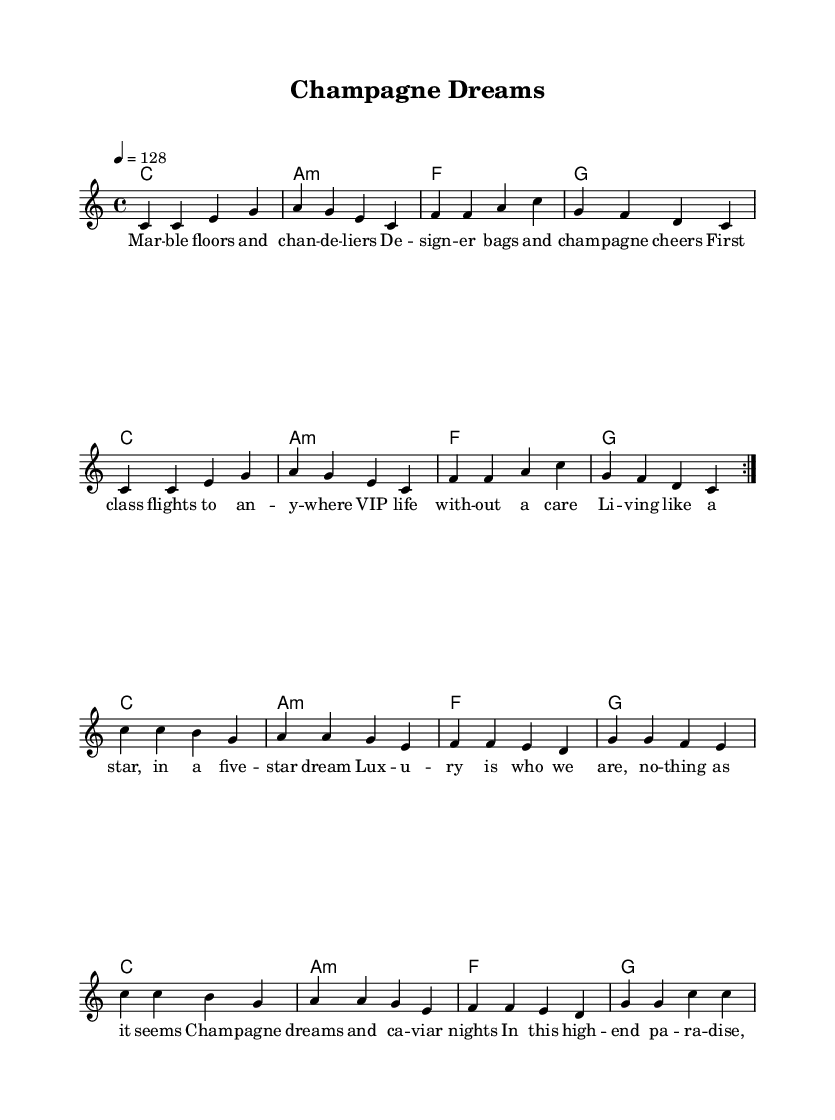What is the key signature of this music? The key signature is C major, which has no sharps or flats.
Answer: C major What is the time signature of the music? The time signature is indicated as 4/4, meaning there are four beats in a measure.
Answer: 4/4 What is the tempo of the piece? The tempo marking indicates 128 beats per minute, denoted by "4 = 128."
Answer: 128 How many measures are used in the chorus? The chorus consists of 8 measures as indicated by the lyric structure and total count of the lines.
Answer: 8 What type of bag is referenced in the lyrics? The lyrics mention "designer bags," indicating luxury items associated with high-end fashion.
Answer: designer bags What kind of lifestyle does the song portray? The lyrics depict a "VIP life" and experiences that suggest an opulent and carefree lifestyle.
Answer: VIP life What do "champagne dreams" symbolize in the song? "Champagne dreams" symbolize luxury, celebration, and high-class living, common themes in K-Pop songs about wealth.
Answer: luxury 